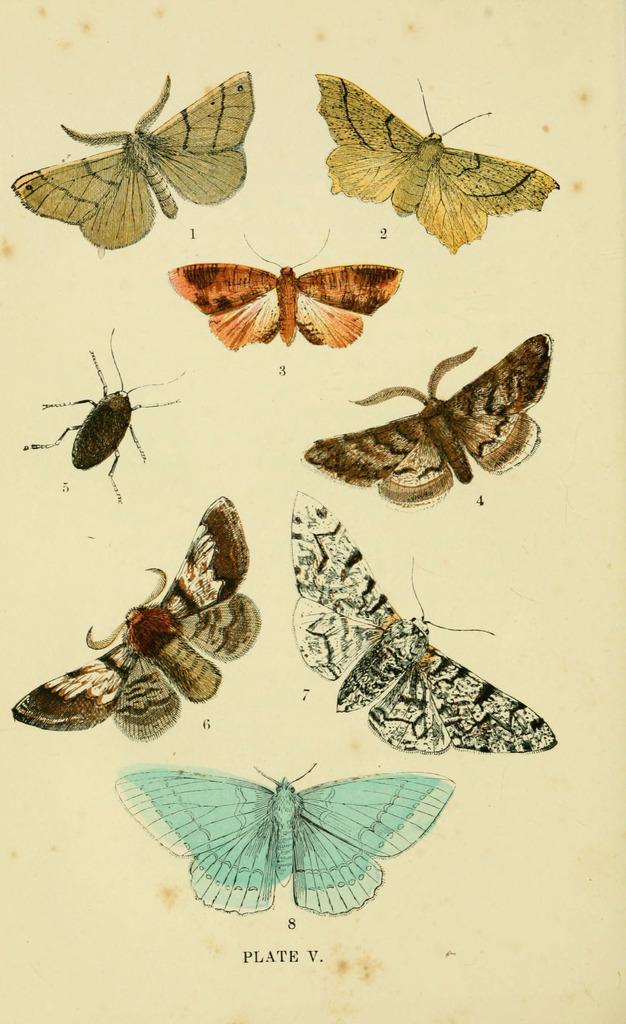How would you summarize this image in a sentence or two? In this image we can see some butterfly and an insect images on a paper, also we can see some text. 